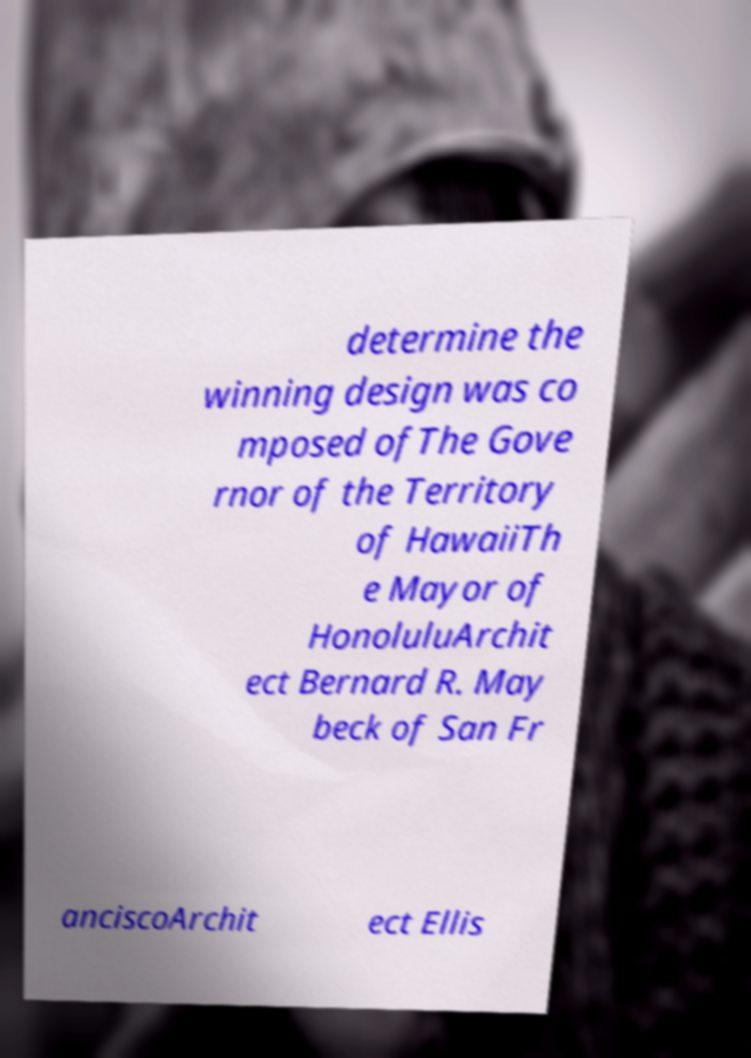What messages or text are displayed in this image? I need them in a readable, typed format. determine the winning design was co mposed ofThe Gove rnor of the Territory of HawaiiTh e Mayor of HonoluluArchit ect Bernard R. May beck of San Fr anciscoArchit ect Ellis 